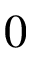<formula> <loc_0><loc_0><loc_500><loc_500>0</formula> 